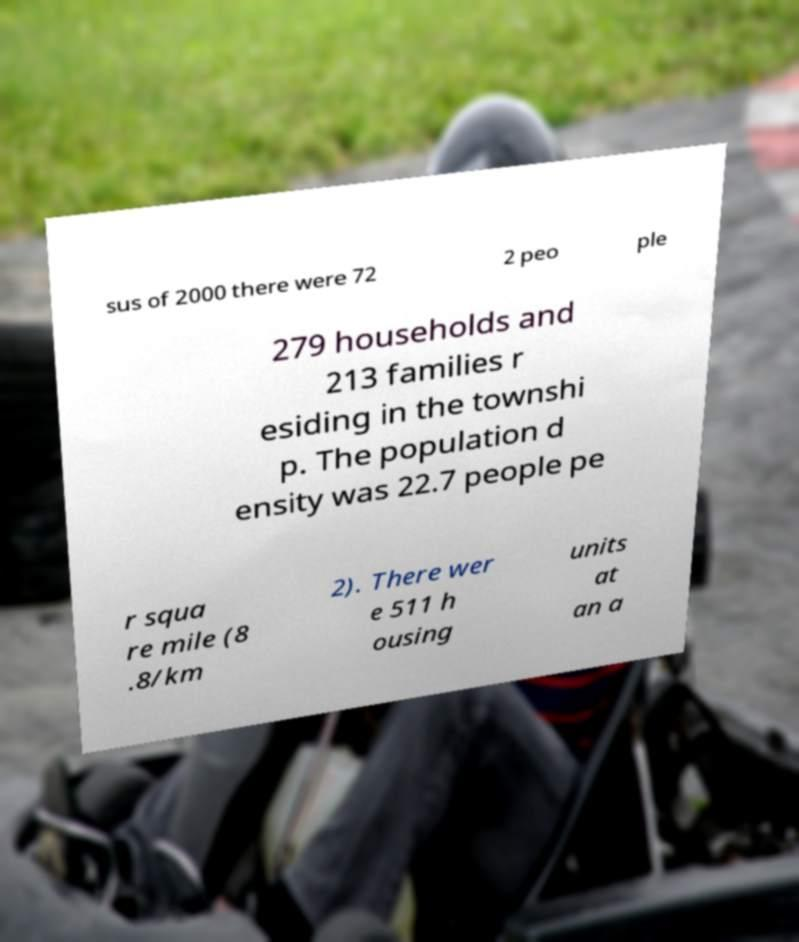Could you extract and type out the text from this image? sus of 2000 there were 72 2 peo ple 279 households and 213 families r esiding in the townshi p. The population d ensity was 22.7 people pe r squa re mile (8 .8/km 2). There wer e 511 h ousing units at an a 